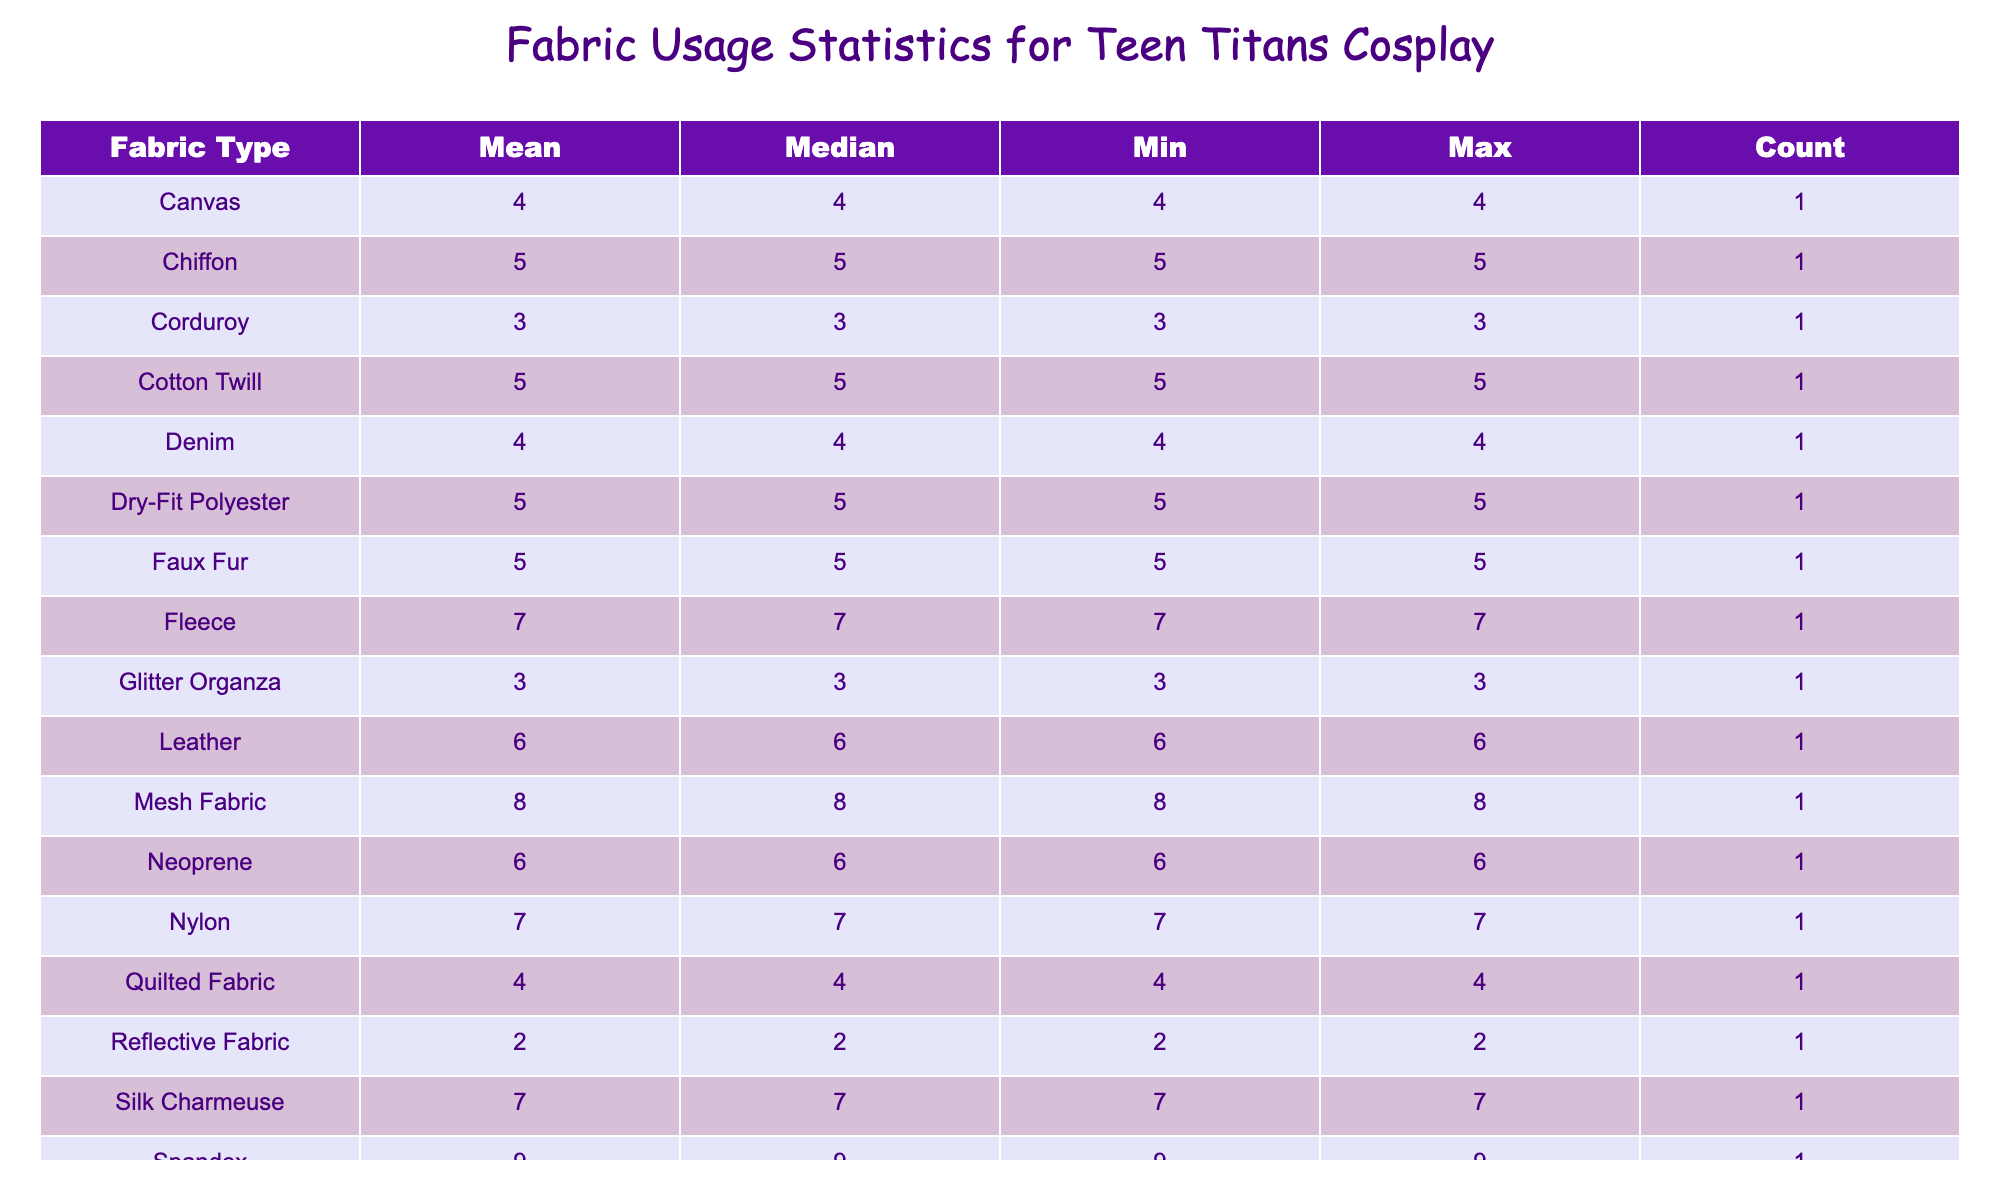What is the total fabric usage for the Spandex fabric type? The table shows that Spandex, used by Wonder Girl in February, has a usage of 9 yards. Since it is the only entry for Spandex, the total usage is simply the value from that entry.
Answer: 9 yards Which fabric type had the highest usage, and how many yards were used? By examining the table, Velvet has the highest usage at a total of 10 yards, as it is the highest value under the 'Usage (yards)' column for any fabric type.
Answer: Velvet, 10 yards What is the average fabric usage for all projects listed in the table? To find the average, we sum all the fabric usage values: 8 + 10 + 5 + 6 + 7 + 4 + 9 + 6 + 5 + 7 + 6 + 8 + 3 + 5 + 4 + 5 + 2 + 4 + 7 + 3 = 103 yards. There are 20 entries, so the average is 103 / 20 = 5.15 yards.
Answer: 5.15 yards Is there any fabric type that has a usage count of more than 2? Looking at the count column for each fabric type, all fabric types have at least one entry, and several fabric types have counts above 2. For example, Velvet and Stretch Satin have 1 entry each, but not more than that. The answer is yes.
Answer: Yes Which month had the lowest total fabric usage, and what was that total? We evaluate the monthly usages: January totals to 8 + 10 + 5 + 6 = 29, February totals to 7 + 4 + 9 + 6 = 26, March totals to 5 + 7 + 6 + 8 = 26, April totals to 3 + 5 + 4 + 5 = 17, and May totals to 2 + 4 + 7 + 3 = 16. Thus, the lowest month is May, with a total of 16 yards.
Answer: May, 16 yards What is the median fabric usage for Neoprene and Fleece combined? Neoprene has a usage of 6 yards, and Fleece has a usage of 7 yards. To find the median of these two values, we arrange them: 6, 7. The median of two numbers is the average of them: (6 + 7) / 2 = 6.5 yards.
Answer: 6.5 yards Does the fabric type "Leather" have the maximum usage among all? The maximum usage in the table is 10 yards for Velvet; Leather has a usage of 6 yards. Since 6 is less than 10, the answer is no.
Answer: No In which month were the most distinct fabric types used? Analyzing the data, January has 4 distinct fabric types, February has 4, March has 4, April has 4, and May has 4. Since all months have the same number, the answer includes months January through May equally.
Answer: January, February, March, April, May 